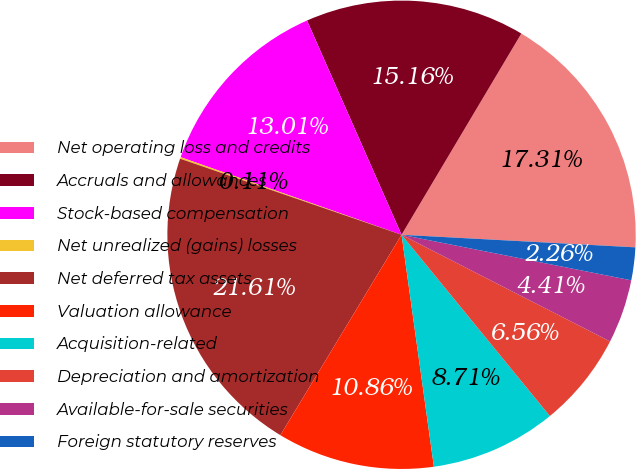Convert chart to OTSL. <chart><loc_0><loc_0><loc_500><loc_500><pie_chart><fcel>Net operating loss and credits<fcel>Accruals and allowances<fcel>Stock-based compensation<fcel>Net unrealized (gains) losses<fcel>Net deferred tax assets<fcel>Valuation allowance<fcel>Acquisition-related<fcel>Depreciation and amortization<fcel>Available-for-sale securities<fcel>Foreign statutory reserves<nl><fcel>17.31%<fcel>15.16%<fcel>13.01%<fcel>0.11%<fcel>21.61%<fcel>10.86%<fcel>8.71%<fcel>6.56%<fcel>4.41%<fcel>2.26%<nl></chart> 